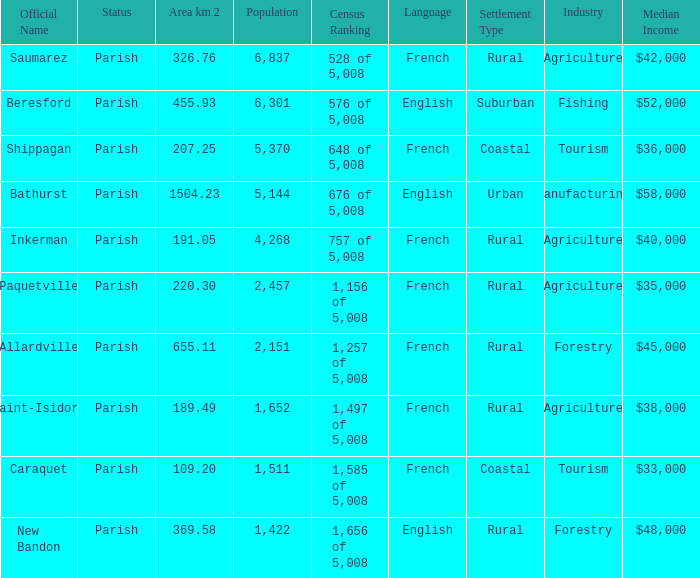What is the Area of the Allardville Parish with a Population smaller than 2,151? None. 